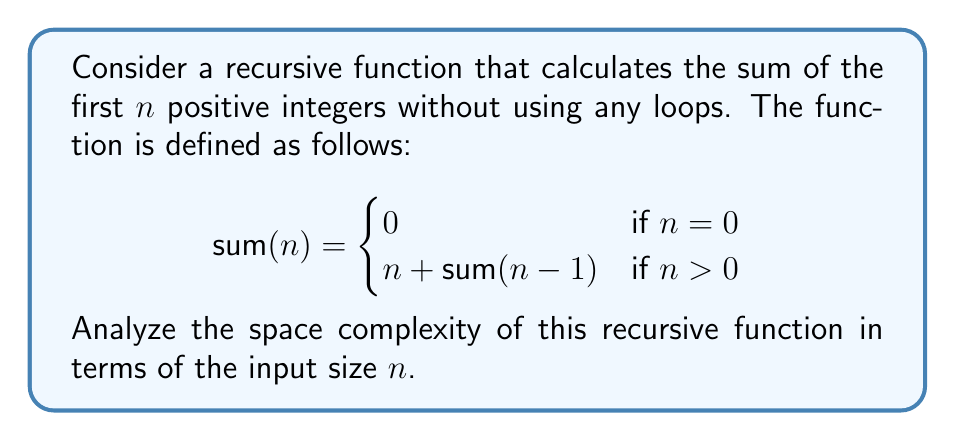Can you answer this question? To analyze the space complexity of this recursive function, we need to consider the maximum depth of the recursion stack and the amount of memory used in each recursive call.

1. Recursion depth:
   The function makes recursive calls until n reaches 0. Each call decreases n by 1.
   Therefore, the number of recursive calls (depth) is equal to n.

2. Memory usage per call:
   In each recursive call, we need to store:
   - The value of n
   - The return address
   - Any local variables (in this case, there are none)

   The space required for these is constant, let's call it c.

3. Total space complexity:
   At the deepest point of recursion, we have n function calls on the stack, each using c amount of space.
   Thus, the total space used is n * c.

4. Asymptotic analysis:
   Since c is a constant, we can express the space complexity in Big O notation as O(n).

It's worth noting that this analysis assumes that the compiler or runtime environment doesn't implement tail-call optimization. If tail-call optimization is implemented, the space complexity could potentially be reduced to O(1), as each recursive call could replace the previous one on the stack.

For a minor with alcohol aversion, we can think of this recursive process as stacking n caffeine-free soda cans, where each can represents a function call. The height of the stack (space used) grows linearly with n.
Answer: The space complexity of the given recursive function is O(n), where n is the input size. 